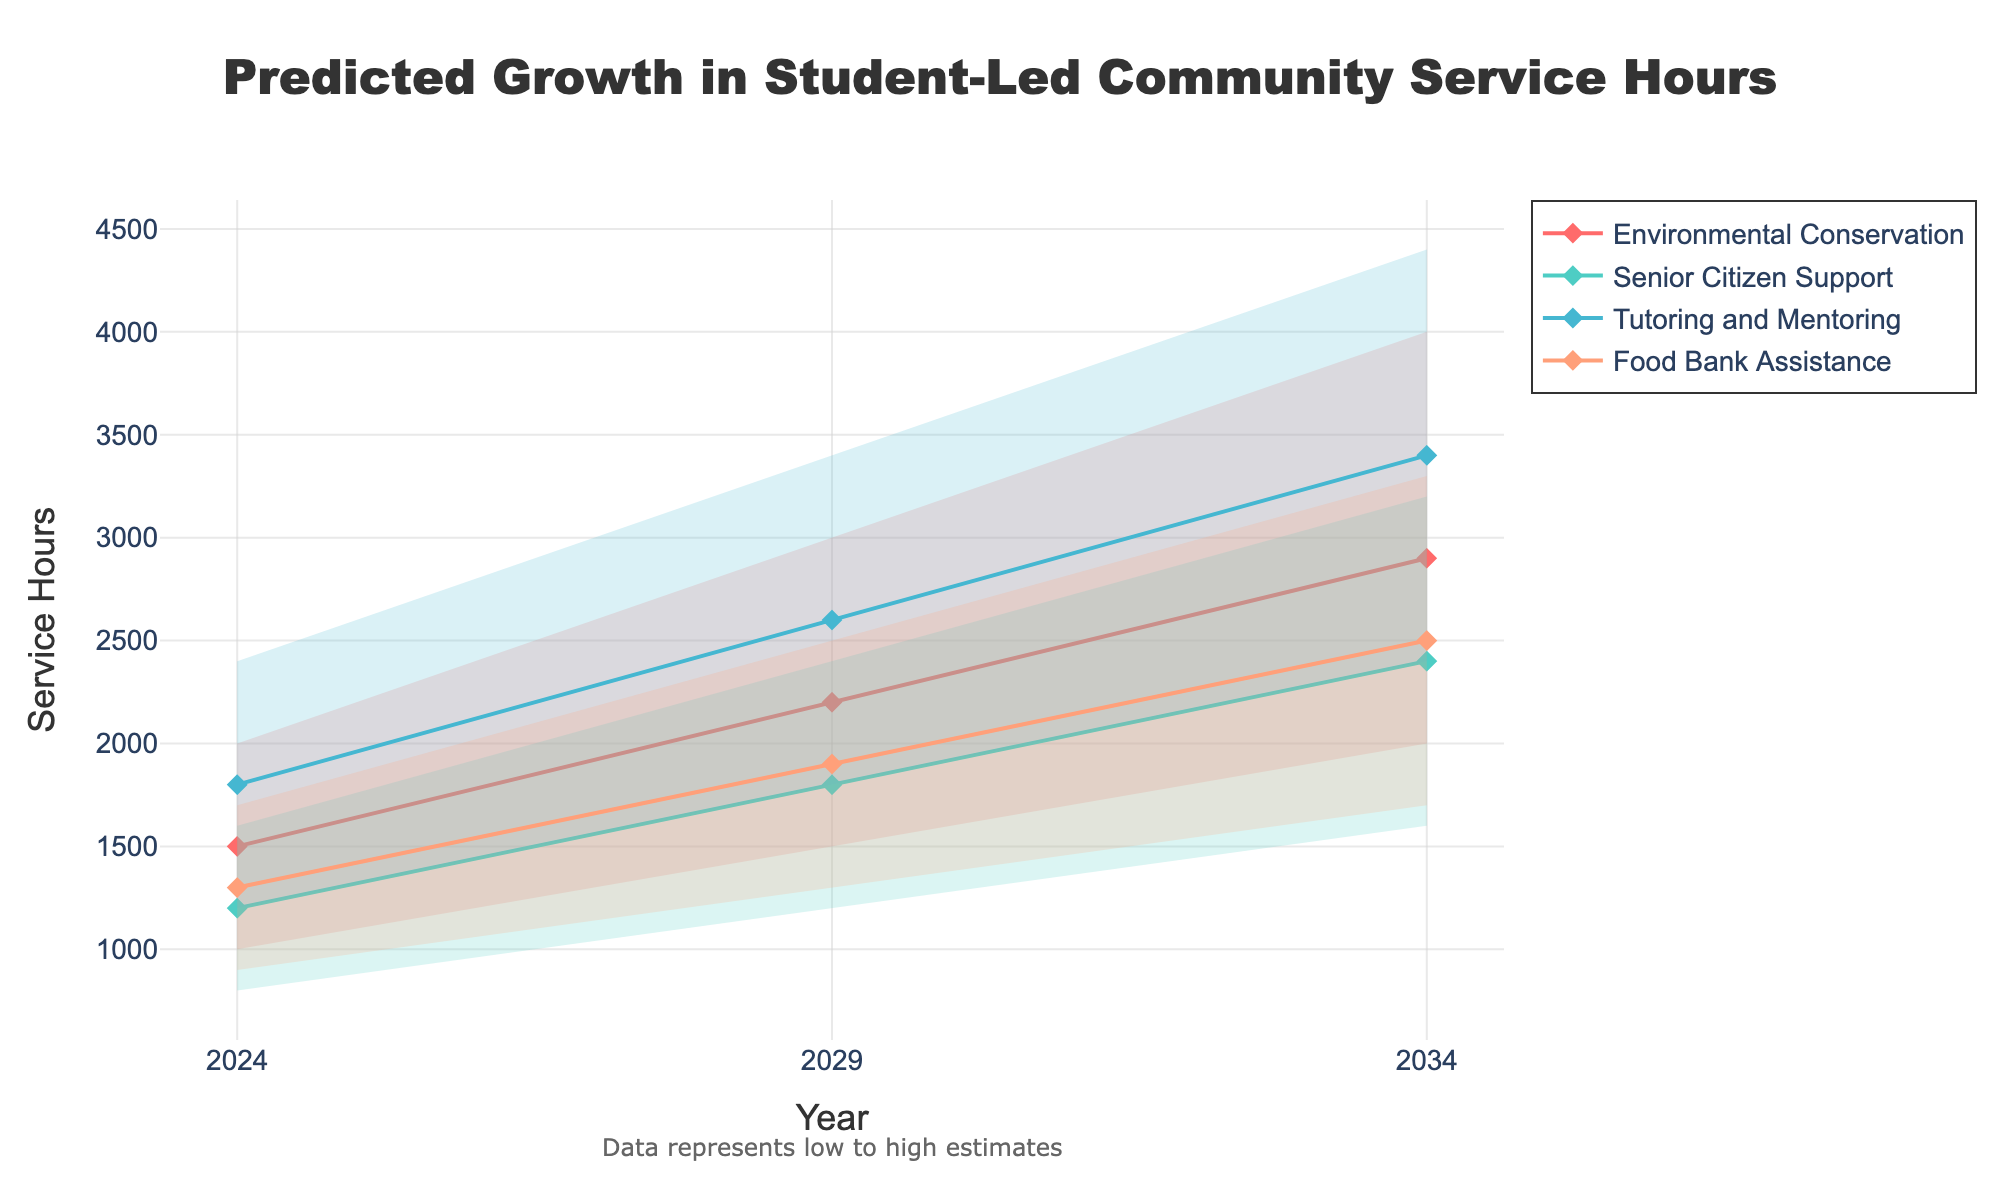What's the title of the figure? The title is usually found at the top of the figure. In this case, the title is "Predicted Growth in Student-Led Community Service Hours."
Answer: Predicted Growth in Student-Led Community Service Hours What is on the x-axis? The x-axis typically represents time or categories. Here, the x-axis is labeled "Year," indicating that it represents different years.
Answer: Year What is on the y-axis? The y-axis generally represents the quantity being measured. In this figure, it is labeled "Service Hours," which indicates the predicted growth in student-led community service hours.
Answer: Service Hours What are the project types displayed in the figure? The project types can be identified by the different colored lines and fill areas. The project types are Environmental Conservation, Senior Citizen Support, Tutoring and Mentoring, and Food Bank Assistance.
Answer: Environmental Conservation, Senior Citizen Support, Tutoring and Mentoring, Food Bank Assistance Which project type has the highest mid estimate of service hours in 2034? First, identify the year 2034 on the x-axis, then look up the mid estimate values for each project type. Tutoring and Mentoring shows the highest mid estimate of 3400 service hours in 2034.
Answer: Tutoring and Mentoring How many years are displayed on the x-axis? The years are shown on the x-axis as tick marks. The figure displays the years 2024, 2029, and 2034, providing a total of three years.
Answer: 3 What is the range of estimates for Food Bank Assistance in 2029? Locate the year 2029 and Food Bank Assistance project type. The range of estimates is from the low estimate (1300) to the high estimate (2500).
Answer: 1300 to 2500 By how much is the mid estimate of Environmental Conservation expected to increase from 2024 to 2029? Find the mid estimates for Environmental Conservation for the years 2024 and 2029. The mid estimate for 2024 is 1500, and for 2029 it is 2200. The increase is 2200 - 1500 = 700 service hours.
Answer: 700 Which project type shows the smallest range of estimates in 2034? In 2034, compare the range (High Estimate - Low Estimate) for each project type. Senior Citizen Support has the smallest range: 3200 - 1600 = 1600 service hours.
Answer: Senior Citizen Support What is the average of the low estimates for Senior Citizen Support across all displayed years? Calculate the average of the low estimates for 2024, 2029, and 2034 as follows: (800 + 1200 + 1600) / 3 = 3600 / 3 = 1200 service hours.
Answer: 1200 